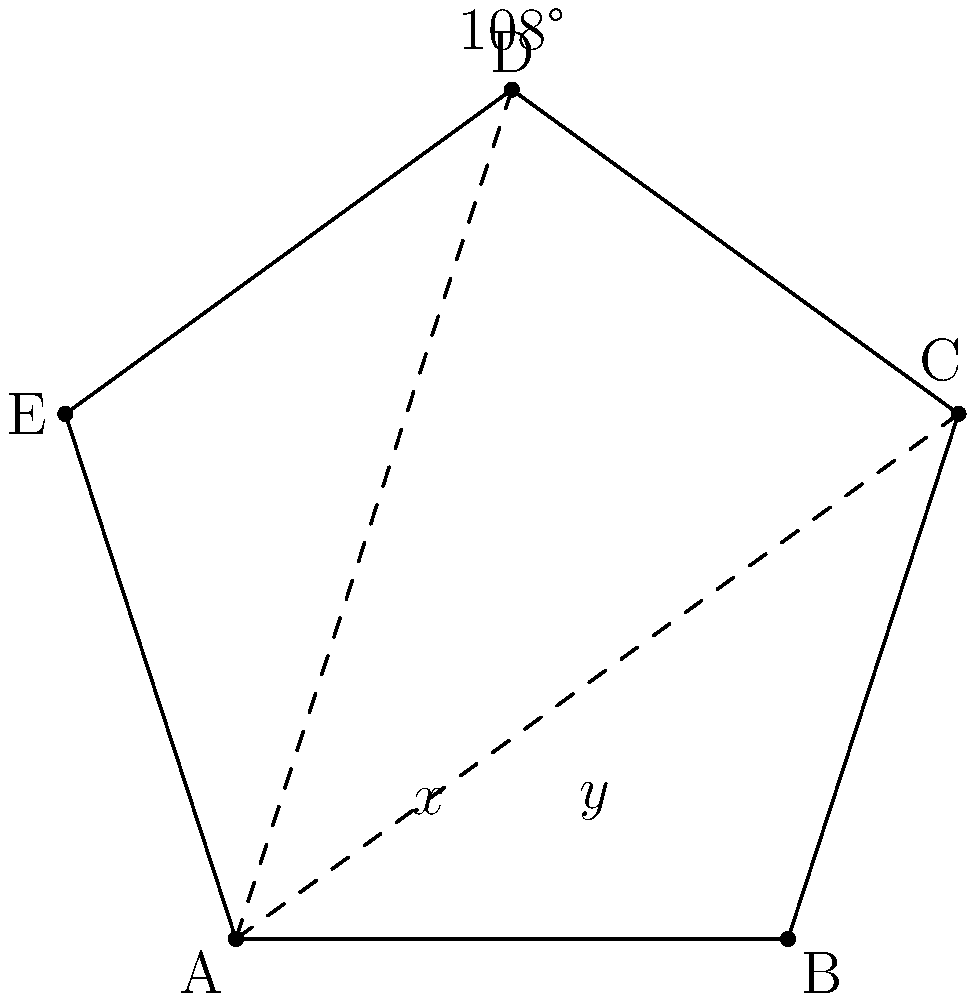Imagine you've won a pentagonal award trophy for your breakthrough role in a children's movie, just like Mason Vale Cotton might have! The trophy's shape is a regular pentagon. If one of the internal angles is labeled as 108°, and two adjacent angles at the base are labeled as $x°$ and $y°$, what is the value of $x + y$? Let's solve this step-by-step:

1) First, recall that in a regular pentagon, all internal angles are equal. The sum of internal angles in a pentagon is $(5-2) \times 180° = 540°$.

2) So, each internal angle of a regular pentagon is $540° \div 5 = 108°$.

3) In the diagram, we see a triangle formed by connecting two non-adjacent vertices of the pentagon. This triangle includes the 108° angle at the top and the two base angles $x°$ and $y°$.

4) We know that the sum of angles in a triangle is always 180°. So:

   $x° + y° + 108° = 180°$

5) Rearranging this equation:

   $x° + y° = 180° - 108° = 72°$

Therefore, the sum of $x$ and $y$ is 72°.
Answer: 72° 